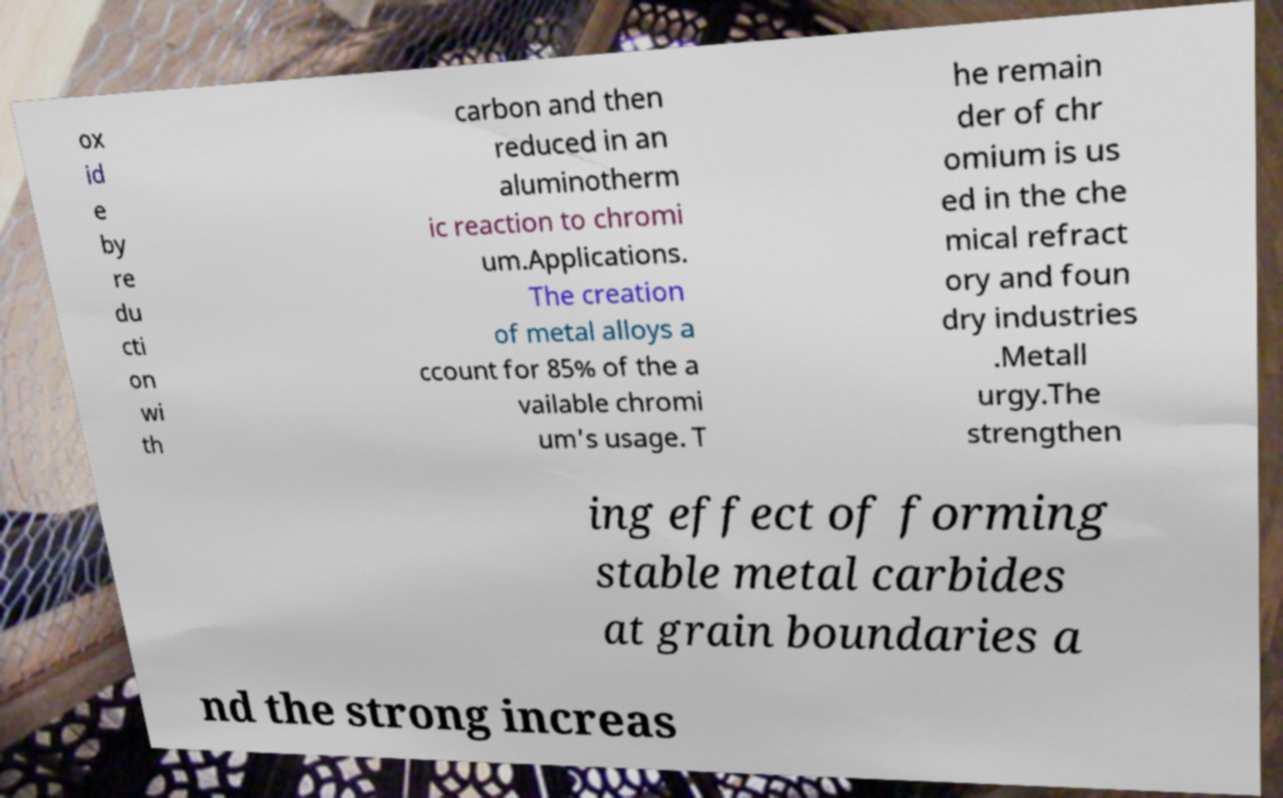Can you read and provide the text displayed in the image?This photo seems to have some interesting text. Can you extract and type it out for me? ox id e by re du cti on wi th carbon and then reduced in an aluminotherm ic reaction to chromi um.Applications. The creation of metal alloys a ccount for 85% of the a vailable chromi um's usage. T he remain der of chr omium is us ed in the che mical refract ory and foun dry industries .Metall urgy.The strengthen ing effect of forming stable metal carbides at grain boundaries a nd the strong increas 